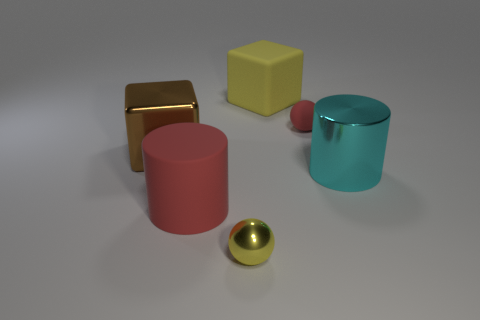Add 2 large metallic cylinders. How many objects exist? 8 Subtract all cylinders. How many objects are left? 4 Add 2 big purple rubber cylinders. How many big purple rubber cylinders exist? 2 Subtract 1 yellow cubes. How many objects are left? 5 Subtract all brown matte blocks. Subtract all big yellow objects. How many objects are left? 5 Add 2 large matte things. How many large matte things are left? 4 